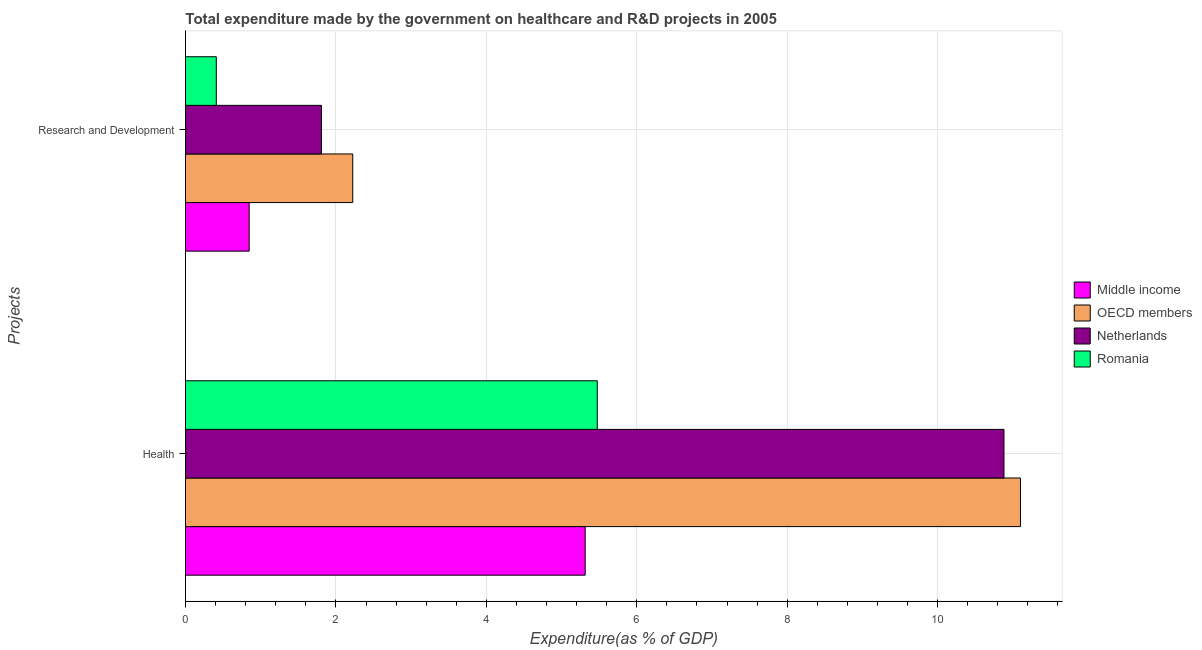Are the number of bars per tick equal to the number of legend labels?
Offer a terse response. Yes. How many bars are there on the 1st tick from the top?
Provide a short and direct response. 4. What is the label of the 1st group of bars from the top?
Your answer should be compact. Research and Development. What is the expenditure in r&d in OECD members?
Give a very brief answer. 2.22. Across all countries, what is the maximum expenditure in r&d?
Offer a very short reply. 2.22. Across all countries, what is the minimum expenditure in r&d?
Your answer should be compact. 0.41. In which country was the expenditure in healthcare maximum?
Your answer should be compact. OECD members. In which country was the expenditure in r&d minimum?
Give a very brief answer. Romania. What is the total expenditure in r&d in the graph?
Offer a terse response. 5.29. What is the difference between the expenditure in healthcare in Middle income and that in OECD members?
Offer a very short reply. -5.79. What is the difference between the expenditure in healthcare in Romania and the expenditure in r&d in OECD members?
Ensure brevity in your answer.  3.25. What is the average expenditure in r&d per country?
Ensure brevity in your answer.  1.32. What is the difference between the expenditure in healthcare and expenditure in r&d in OECD members?
Offer a very short reply. 8.88. In how many countries, is the expenditure in r&d greater than 5.2 %?
Offer a terse response. 0. What is the ratio of the expenditure in r&d in Romania to that in Netherlands?
Keep it short and to the point. 0.23. Is the expenditure in healthcare in OECD members less than that in Romania?
Your answer should be very brief. No. In how many countries, is the expenditure in healthcare greater than the average expenditure in healthcare taken over all countries?
Your response must be concise. 2. What does the 4th bar from the top in Health represents?
Your answer should be compact. Middle income. What does the 1st bar from the bottom in Research and Development represents?
Your response must be concise. Middle income. Are all the bars in the graph horizontal?
Ensure brevity in your answer.  Yes. Where does the legend appear in the graph?
Offer a terse response. Center right. How many legend labels are there?
Provide a short and direct response. 4. How are the legend labels stacked?
Make the answer very short. Vertical. What is the title of the graph?
Your response must be concise. Total expenditure made by the government on healthcare and R&D projects in 2005. Does "Low income" appear as one of the legend labels in the graph?
Your response must be concise. No. What is the label or title of the X-axis?
Provide a succinct answer. Expenditure(as % of GDP). What is the label or title of the Y-axis?
Give a very brief answer. Projects. What is the Expenditure(as % of GDP) of Middle income in Health?
Provide a short and direct response. 5.31. What is the Expenditure(as % of GDP) in OECD members in Health?
Ensure brevity in your answer.  11.1. What is the Expenditure(as % of GDP) in Netherlands in Health?
Keep it short and to the point. 10.88. What is the Expenditure(as % of GDP) in Romania in Health?
Provide a succinct answer. 5.48. What is the Expenditure(as % of GDP) in Middle income in Research and Development?
Your answer should be compact. 0.85. What is the Expenditure(as % of GDP) of OECD members in Research and Development?
Your answer should be very brief. 2.22. What is the Expenditure(as % of GDP) in Netherlands in Research and Development?
Provide a succinct answer. 1.81. What is the Expenditure(as % of GDP) in Romania in Research and Development?
Ensure brevity in your answer.  0.41. Across all Projects, what is the maximum Expenditure(as % of GDP) of Middle income?
Offer a very short reply. 5.31. Across all Projects, what is the maximum Expenditure(as % of GDP) of OECD members?
Your answer should be compact. 11.1. Across all Projects, what is the maximum Expenditure(as % of GDP) of Netherlands?
Offer a terse response. 10.88. Across all Projects, what is the maximum Expenditure(as % of GDP) in Romania?
Your response must be concise. 5.48. Across all Projects, what is the minimum Expenditure(as % of GDP) of Middle income?
Offer a very short reply. 0.85. Across all Projects, what is the minimum Expenditure(as % of GDP) in OECD members?
Give a very brief answer. 2.22. Across all Projects, what is the minimum Expenditure(as % of GDP) of Netherlands?
Make the answer very short. 1.81. Across all Projects, what is the minimum Expenditure(as % of GDP) of Romania?
Ensure brevity in your answer.  0.41. What is the total Expenditure(as % of GDP) in Middle income in the graph?
Provide a succinct answer. 6.16. What is the total Expenditure(as % of GDP) in OECD members in the graph?
Keep it short and to the point. 13.33. What is the total Expenditure(as % of GDP) in Netherlands in the graph?
Ensure brevity in your answer.  12.69. What is the total Expenditure(as % of GDP) of Romania in the graph?
Your answer should be compact. 5.88. What is the difference between the Expenditure(as % of GDP) in Middle income in Health and that in Research and Development?
Provide a succinct answer. 4.47. What is the difference between the Expenditure(as % of GDP) in OECD members in Health and that in Research and Development?
Provide a short and direct response. 8.88. What is the difference between the Expenditure(as % of GDP) of Netherlands in Health and that in Research and Development?
Offer a terse response. 9.07. What is the difference between the Expenditure(as % of GDP) of Romania in Health and that in Research and Development?
Ensure brevity in your answer.  5.07. What is the difference between the Expenditure(as % of GDP) in Middle income in Health and the Expenditure(as % of GDP) in OECD members in Research and Development?
Give a very brief answer. 3.09. What is the difference between the Expenditure(as % of GDP) of Middle income in Health and the Expenditure(as % of GDP) of Netherlands in Research and Development?
Your answer should be very brief. 3.51. What is the difference between the Expenditure(as % of GDP) in Middle income in Health and the Expenditure(as % of GDP) in Romania in Research and Development?
Your answer should be compact. 4.9. What is the difference between the Expenditure(as % of GDP) of OECD members in Health and the Expenditure(as % of GDP) of Netherlands in Research and Development?
Offer a very short reply. 9.29. What is the difference between the Expenditure(as % of GDP) in OECD members in Health and the Expenditure(as % of GDP) in Romania in Research and Development?
Your answer should be compact. 10.69. What is the difference between the Expenditure(as % of GDP) in Netherlands in Health and the Expenditure(as % of GDP) in Romania in Research and Development?
Provide a short and direct response. 10.47. What is the average Expenditure(as % of GDP) in Middle income per Projects?
Your response must be concise. 3.08. What is the average Expenditure(as % of GDP) in OECD members per Projects?
Give a very brief answer. 6.66. What is the average Expenditure(as % of GDP) of Netherlands per Projects?
Your answer should be very brief. 6.34. What is the average Expenditure(as % of GDP) in Romania per Projects?
Ensure brevity in your answer.  2.94. What is the difference between the Expenditure(as % of GDP) in Middle income and Expenditure(as % of GDP) in OECD members in Health?
Keep it short and to the point. -5.79. What is the difference between the Expenditure(as % of GDP) in Middle income and Expenditure(as % of GDP) in Netherlands in Health?
Offer a terse response. -5.57. What is the difference between the Expenditure(as % of GDP) of Middle income and Expenditure(as % of GDP) of Romania in Health?
Provide a short and direct response. -0.16. What is the difference between the Expenditure(as % of GDP) of OECD members and Expenditure(as % of GDP) of Netherlands in Health?
Offer a very short reply. 0.22. What is the difference between the Expenditure(as % of GDP) of OECD members and Expenditure(as % of GDP) of Romania in Health?
Keep it short and to the point. 5.63. What is the difference between the Expenditure(as % of GDP) in Netherlands and Expenditure(as % of GDP) in Romania in Health?
Your answer should be compact. 5.41. What is the difference between the Expenditure(as % of GDP) in Middle income and Expenditure(as % of GDP) in OECD members in Research and Development?
Keep it short and to the point. -1.38. What is the difference between the Expenditure(as % of GDP) in Middle income and Expenditure(as % of GDP) in Netherlands in Research and Development?
Keep it short and to the point. -0.96. What is the difference between the Expenditure(as % of GDP) of Middle income and Expenditure(as % of GDP) of Romania in Research and Development?
Keep it short and to the point. 0.44. What is the difference between the Expenditure(as % of GDP) of OECD members and Expenditure(as % of GDP) of Netherlands in Research and Development?
Provide a short and direct response. 0.42. What is the difference between the Expenditure(as % of GDP) of OECD members and Expenditure(as % of GDP) of Romania in Research and Development?
Provide a short and direct response. 1.81. What is the difference between the Expenditure(as % of GDP) in Netherlands and Expenditure(as % of GDP) in Romania in Research and Development?
Your answer should be compact. 1.4. What is the ratio of the Expenditure(as % of GDP) of Middle income in Health to that in Research and Development?
Keep it short and to the point. 6.28. What is the ratio of the Expenditure(as % of GDP) of OECD members in Health to that in Research and Development?
Your response must be concise. 4.99. What is the ratio of the Expenditure(as % of GDP) in Netherlands in Health to that in Research and Development?
Offer a terse response. 6.02. What is the ratio of the Expenditure(as % of GDP) of Romania in Health to that in Research and Development?
Offer a terse response. 13.37. What is the difference between the highest and the second highest Expenditure(as % of GDP) in Middle income?
Your answer should be very brief. 4.47. What is the difference between the highest and the second highest Expenditure(as % of GDP) of OECD members?
Offer a very short reply. 8.88. What is the difference between the highest and the second highest Expenditure(as % of GDP) of Netherlands?
Provide a succinct answer. 9.07. What is the difference between the highest and the second highest Expenditure(as % of GDP) of Romania?
Your answer should be compact. 5.07. What is the difference between the highest and the lowest Expenditure(as % of GDP) of Middle income?
Provide a succinct answer. 4.47. What is the difference between the highest and the lowest Expenditure(as % of GDP) in OECD members?
Ensure brevity in your answer.  8.88. What is the difference between the highest and the lowest Expenditure(as % of GDP) of Netherlands?
Provide a succinct answer. 9.07. What is the difference between the highest and the lowest Expenditure(as % of GDP) in Romania?
Your answer should be compact. 5.07. 